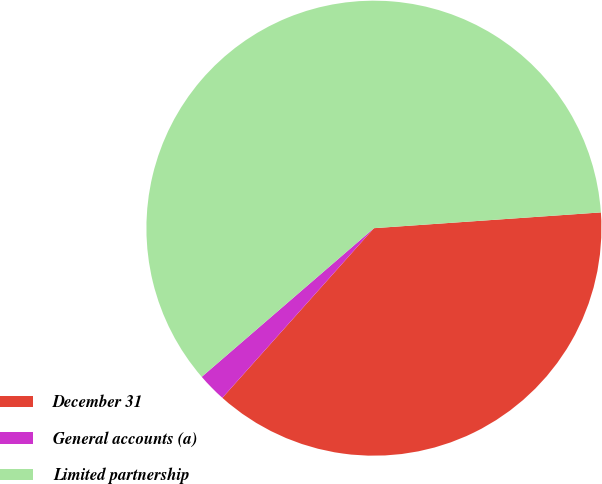Convert chart to OTSL. <chart><loc_0><loc_0><loc_500><loc_500><pie_chart><fcel>December 31<fcel>General accounts (a)<fcel>Limited partnership<nl><fcel>37.71%<fcel>2.06%<fcel>60.23%<nl></chart> 